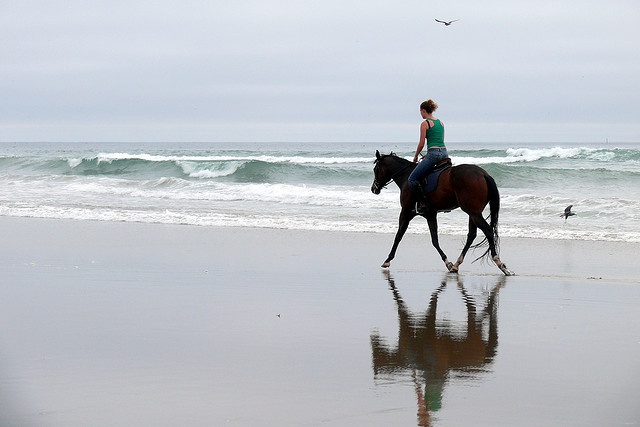Describe the objects in this image and their specific colors. I can see horse in lightgray, black, darkgray, and gray tones, people in lightgray, black, teal, gray, and brown tones, bird in lightgray, darkgray, gray, and black tones, and bird in lightgray, gray, black, and darkgray tones in this image. 